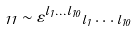Convert formula to latex. <formula><loc_0><loc_0><loc_500><loc_500>\Gamma _ { 1 1 } \sim \varepsilon ^ { l _ { 1 } \dots l _ { 1 0 } } \Gamma _ { l _ { 1 } } \dots \Gamma _ { l _ { 1 0 } }</formula> 